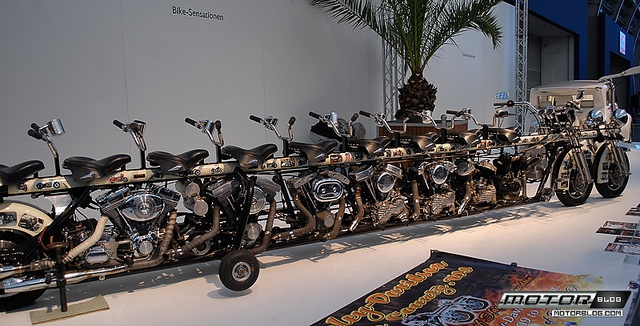Describe the objects in this image and their specific colors. I can see motorcycle in gray, black, darkgray, and tan tones, motorcycle in gray, black, and darkgray tones, motorcycle in gray, black, maroon, and darkgray tones, motorcycle in gray, black, and darkgray tones, and motorcycle in gray, black, and maroon tones in this image. 